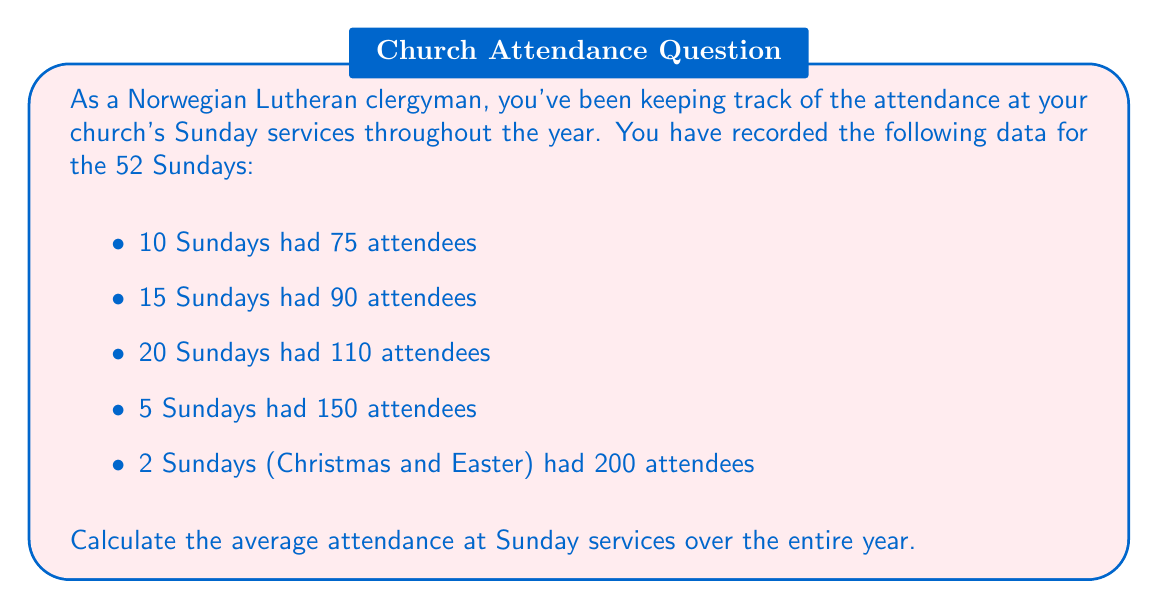Help me with this question. To calculate the average attendance, we need to follow these steps:

1. Calculate the total number of attendees for the year:
   We multiply each attendance number by the number of Sundays it occurred, then sum these products.

   $$(75 \times 10) + (90 \times 15) + (110 \times 20) + (150 \times 5) + (200 \times 2)$$
   $$= 750 + 1350 + 2200 + 750 + 400$$
   $$= 5450\text{ total attendees}$$

2. Calculate the total number of Sundays:
   We sum the number of Sundays for each attendance level.

   $$10 + 15 + 20 + 5 + 2 = 52\text{ Sundays}$$

3. Calculate the average attendance:
   We divide the total number of attendees by the total number of Sundays.

   $$\text{Average Attendance} = \frac{\text{Total Attendees}}{\text{Total Sundays}}$$

   $$= \frac{5450}{52}$$
   
   $$\approx 104.81$$

Therefore, the average attendance at Sunday services over the year is approximately 104.81 people.
Answer: The average attendance at Sunday services over the year is approximately 104.81 people. 